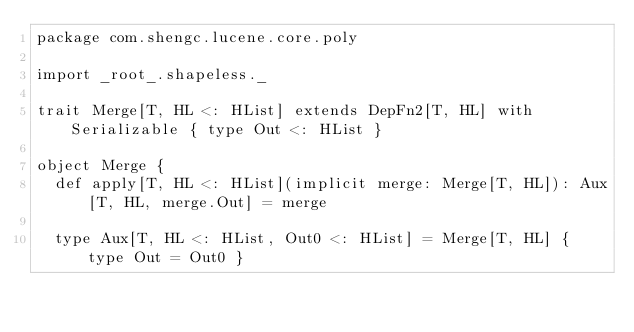Convert code to text. <code><loc_0><loc_0><loc_500><loc_500><_Scala_>package com.shengc.lucene.core.poly

import _root_.shapeless._

trait Merge[T, HL <: HList] extends DepFn2[T, HL] with Serializable { type Out <: HList }

object Merge {
  def apply[T, HL <: HList](implicit merge: Merge[T, HL]): Aux[T, HL, merge.Out] = merge

  type Aux[T, HL <: HList, Out0 <: HList] = Merge[T, HL] { type Out = Out0 }
</code> 